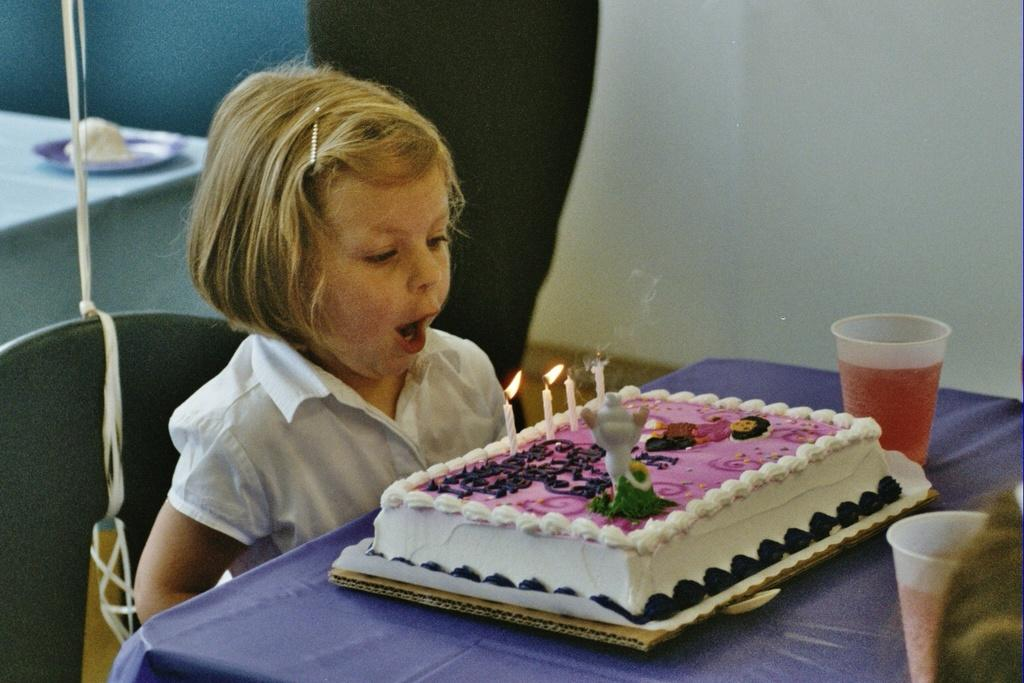What is the person in the image doing? The person is sitting in the image. What is the person wearing? The person is wearing a white dress. What type of food can be seen in the image? There is a cake in the image. What might be used for drinking in the image? There are cups in the image. What can be seen on the table in the image? There are objects on the table. What is visible in the background of the image? There is a wall visible in the background. What type of nail is being hammered into the wall in the image? There is no nail being hammered into the wall in the image. What type of rod can be seen supporting the cake in the image? There is no rod supporting the cake in the image. 